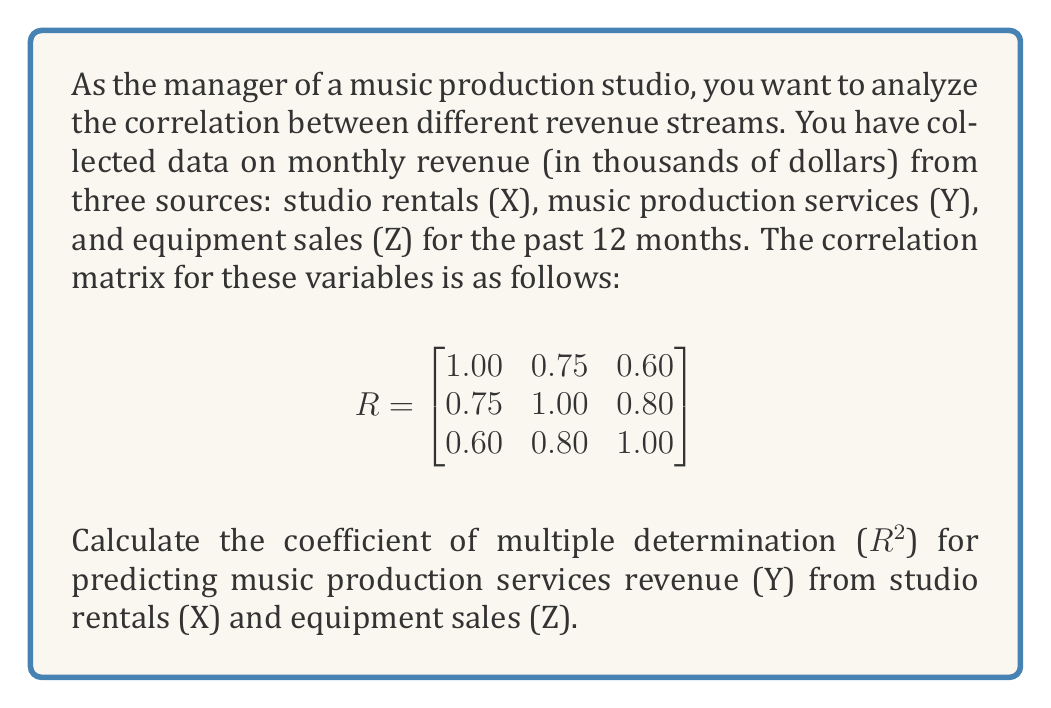Give your solution to this math problem. To calculate the coefficient of multiple determination (R²) for predicting Y from X and Z, we'll follow these steps:

1) The formula for R² in a multiple regression with two predictor variables is:

   $$R^2 = \frac{r_{yx}^2 + r_{yz}^2 - 2r_{yx}r_{yz}r_{xz}}{1 - r_{xz}^2}$$

   where $r_{yx}$, $r_{yz}$, and $r_{xz}$ are the correlation coefficients between the respective variables.

2) From the given correlation matrix:
   $r_{yx} = 0.75$
   $r_{yz} = 0.80$
   $r_{xz} = 0.60$

3) Let's substitute these values into the formula:

   $$R^2 = \frac{0.75^2 + 0.80^2 - 2(0.75)(0.80)(0.60)}{1 - 0.60^2}$$

4) Calculate the numerator:
   $0.75^2 = 0.5625$
   $0.80^2 = 0.6400$
   $2(0.75)(0.80)(0.60) = 0.7200$
   
   Numerator = $0.5625 + 0.6400 - 0.7200 = 0.4825$

5) Calculate the denominator:
   $1 - 0.60^2 = 1 - 0.36 = 0.64$

6) Divide the numerator by the denominator:

   $$R^2 = \frac{0.4825}{0.64} = 0.7539$$

7) Round to two decimal places: $R^2 = 0.75$
Answer: 0.75 